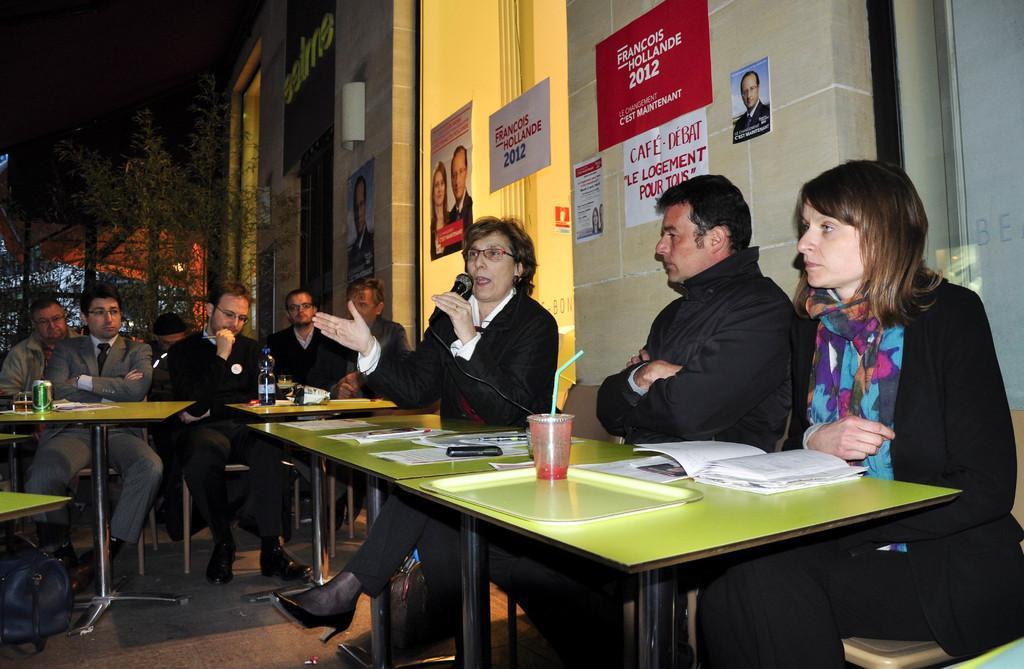How would you summarize this image in a sentence or two? This is the picture where we can see a group of people sitting on chairs in front of a table and on table we can see a tray, glass, phone and a paper behind them there is wall on which some postures are been posted in red, white color and there is a bag on the floor. 